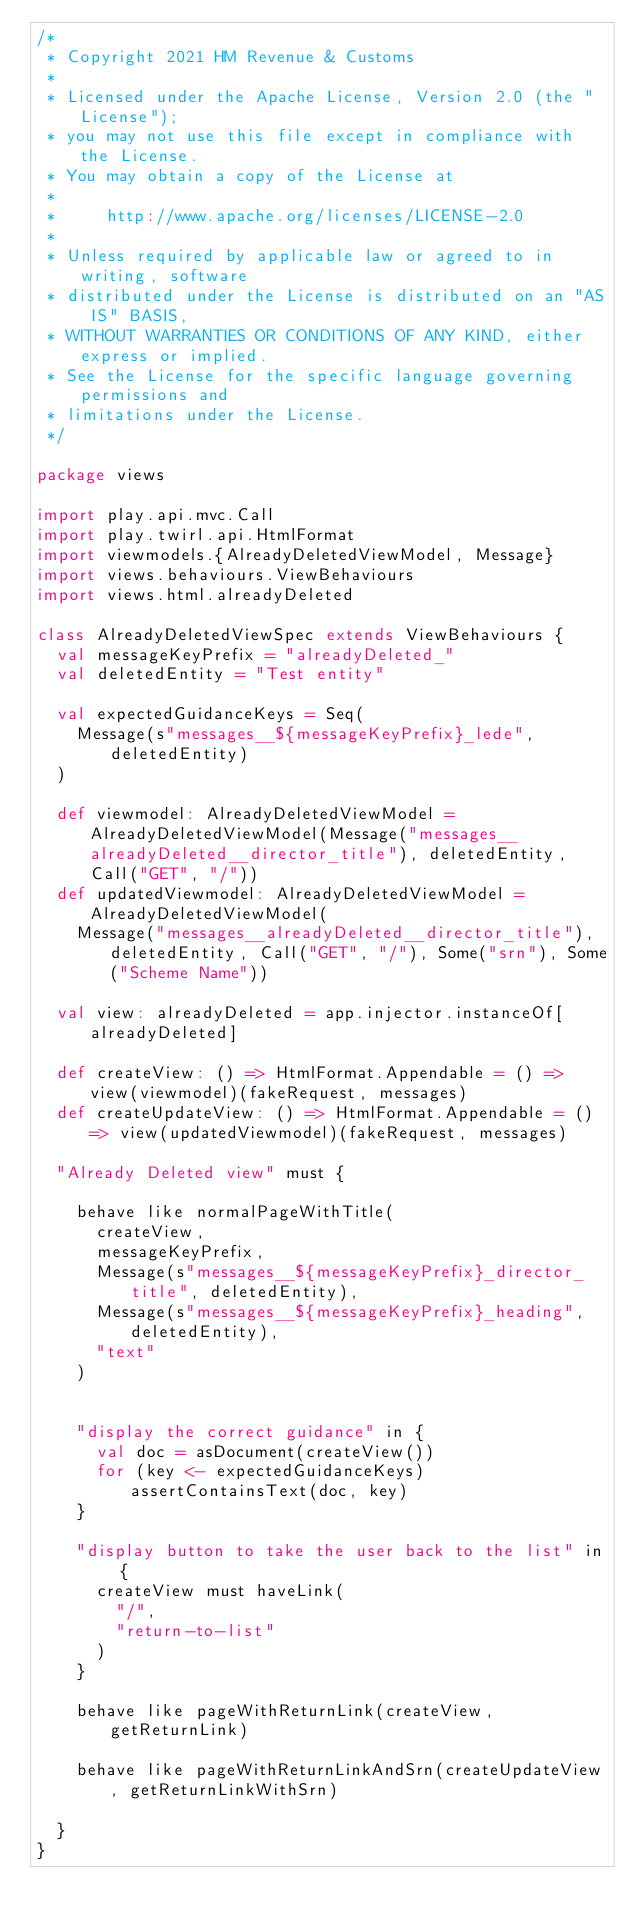Convert code to text. <code><loc_0><loc_0><loc_500><loc_500><_Scala_>/*
 * Copyright 2021 HM Revenue & Customs
 *
 * Licensed under the Apache License, Version 2.0 (the "License");
 * you may not use this file except in compliance with the License.
 * You may obtain a copy of the License at
 *
 *     http://www.apache.org/licenses/LICENSE-2.0
 *
 * Unless required by applicable law or agreed to in writing, software
 * distributed under the License is distributed on an "AS IS" BASIS,
 * WITHOUT WARRANTIES OR CONDITIONS OF ANY KIND, either express or implied.
 * See the License for the specific language governing permissions and
 * limitations under the License.
 */

package views

import play.api.mvc.Call
import play.twirl.api.HtmlFormat
import viewmodels.{AlreadyDeletedViewModel, Message}
import views.behaviours.ViewBehaviours
import views.html.alreadyDeleted

class AlreadyDeletedViewSpec extends ViewBehaviours {
  val messageKeyPrefix = "alreadyDeleted_"
  val deletedEntity = "Test entity"

  val expectedGuidanceKeys = Seq(
    Message(s"messages__${messageKeyPrefix}_lede", deletedEntity)
  )

  def viewmodel: AlreadyDeletedViewModel = AlreadyDeletedViewModel(Message("messages__alreadyDeleted__director_title"), deletedEntity, Call("GET", "/"))
  def updatedViewmodel: AlreadyDeletedViewModel = AlreadyDeletedViewModel(
    Message("messages__alreadyDeleted__director_title"), deletedEntity, Call("GET", "/"), Some("srn"), Some("Scheme Name"))

  val view: alreadyDeleted = app.injector.instanceOf[alreadyDeleted]

  def createView: () => HtmlFormat.Appendable = () => view(viewmodel)(fakeRequest, messages)
  def createUpdateView: () => HtmlFormat.Appendable = () => view(updatedViewmodel)(fakeRequest, messages)

  "Already Deleted view" must {

    behave like normalPageWithTitle(
      createView,
      messageKeyPrefix,
      Message(s"messages__${messageKeyPrefix}_director_title", deletedEntity),
      Message(s"messages__${messageKeyPrefix}_heading", deletedEntity),
      "text"
    )


    "display the correct guidance" in {
      val doc = asDocument(createView())
      for (key <- expectedGuidanceKeys) assertContainsText(doc, key)
    }

    "display button to take the user back to the list" in {
      createView must haveLink(
        "/",
        "return-to-list"
      )
    }

    behave like pageWithReturnLink(createView, getReturnLink)

    behave like pageWithReturnLinkAndSrn(createUpdateView, getReturnLinkWithSrn)

  }
}</code> 